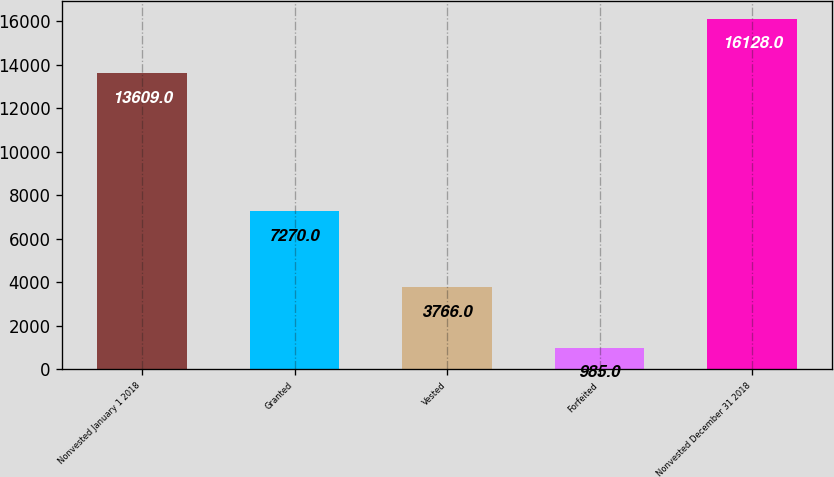<chart> <loc_0><loc_0><loc_500><loc_500><bar_chart><fcel>Nonvested January 1 2018<fcel>Granted<fcel>Vested<fcel>Forfeited<fcel>Nonvested December 31 2018<nl><fcel>13609<fcel>7270<fcel>3766<fcel>985<fcel>16128<nl></chart> 